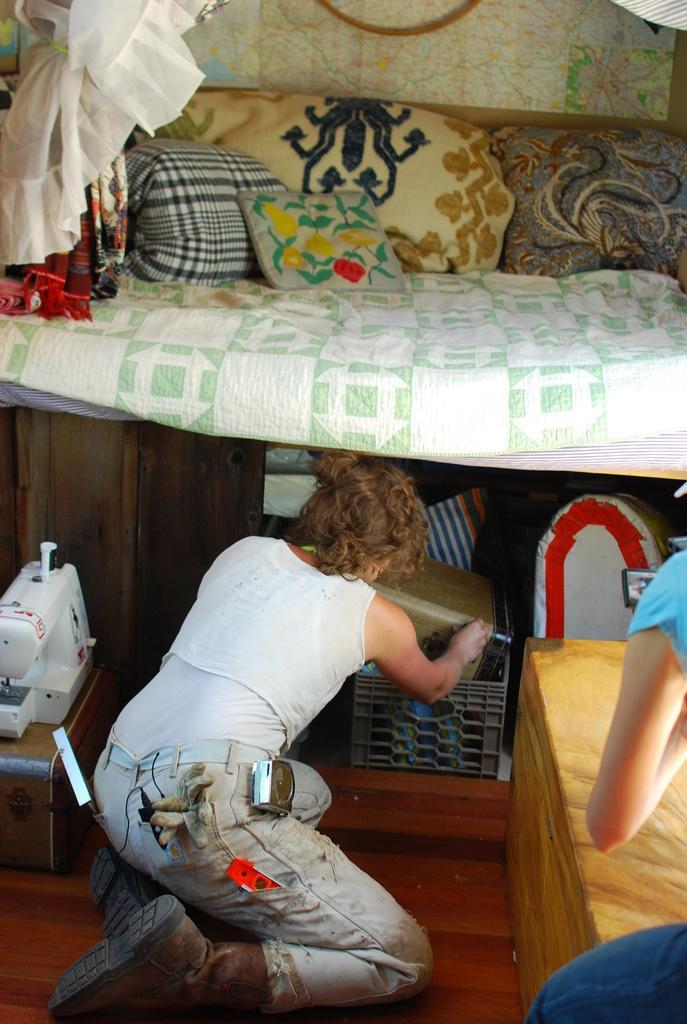Please provide a concise description of this image. In this picture we can see two people, here we can see a floor, wooden objects, pillows, clothes and some objects. 